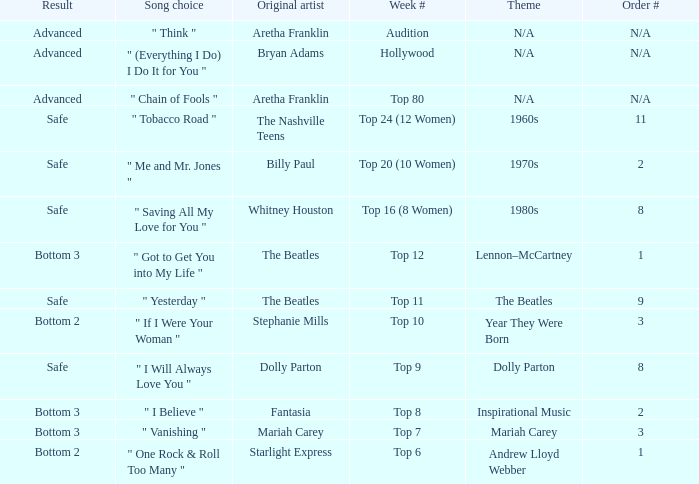Name the song choice when week number is hollywood " (Everything I Do) I Do It for You ". 